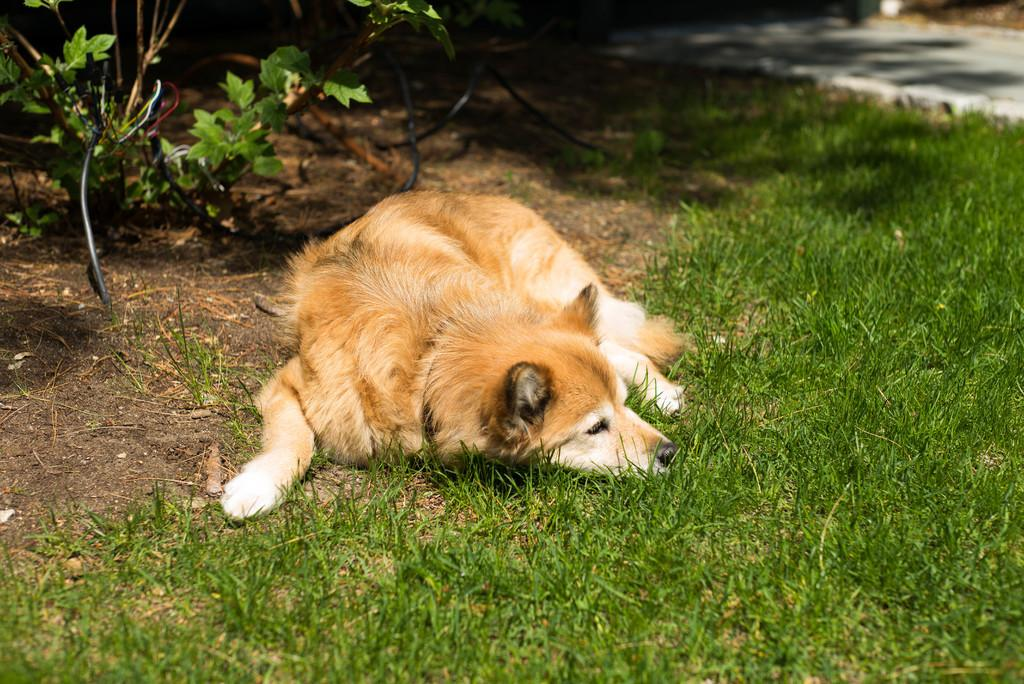What animal can be seen lying on the land in the image? There is a dog lying on the land in the image. What type of vegetation is present in the image? There is a plant and grass in the image. What man-made structures can be seen in the image? There are wires and a road visible in the image. What type of glue is being used to hold the island together in the image? There is no island present in the image, and therefore no glue or need to hold it together. 